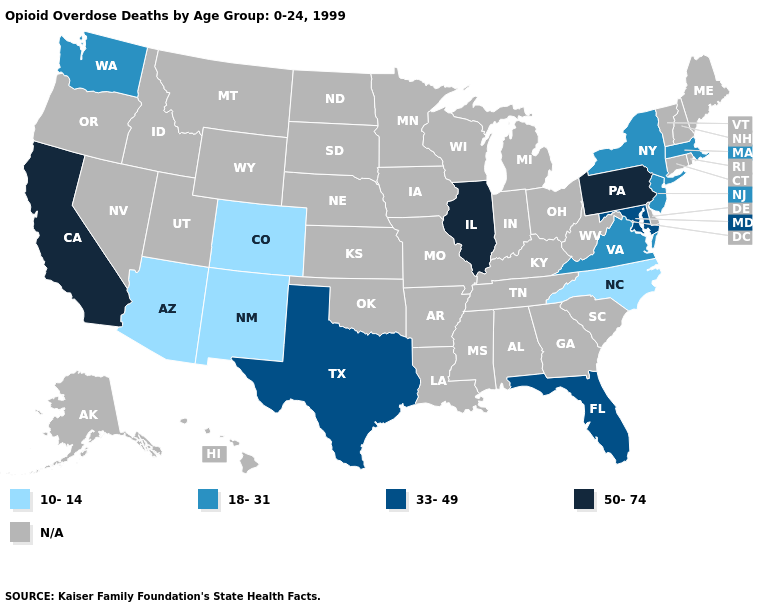Name the states that have a value in the range 33-49?
Write a very short answer. Florida, Maryland, Texas. Does New Jersey have the highest value in the USA?
Give a very brief answer. No. Name the states that have a value in the range N/A?
Give a very brief answer. Alabama, Alaska, Arkansas, Connecticut, Delaware, Georgia, Hawaii, Idaho, Indiana, Iowa, Kansas, Kentucky, Louisiana, Maine, Michigan, Minnesota, Mississippi, Missouri, Montana, Nebraska, Nevada, New Hampshire, North Dakota, Ohio, Oklahoma, Oregon, Rhode Island, South Carolina, South Dakota, Tennessee, Utah, Vermont, West Virginia, Wisconsin, Wyoming. Does Texas have the highest value in the South?
Concise answer only. Yes. Does Pennsylvania have the highest value in the USA?
Be succinct. Yes. How many symbols are there in the legend?
Short answer required. 5. Name the states that have a value in the range 33-49?
Concise answer only. Florida, Maryland, Texas. Does Pennsylvania have the highest value in the USA?
Short answer required. Yes. What is the value of Missouri?
Write a very short answer. N/A. Is the legend a continuous bar?
Quick response, please. No. Which states have the highest value in the USA?
Quick response, please. California, Illinois, Pennsylvania. Name the states that have a value in the range N/A?
Quick response, please. Alabama, Alaska, Arkansas, Connecticut, Delaware, Georgia, Hawaii, Idaho, Indiana, Iowa, Kansas, Kentucky, Louisiana, Maine, Michigan, Minnesota, Mississippi, Missouri, Montana, Nebraska, Nevada, New Hampshire, North Dakota, Ohio, Oklahoma, Oregon, Rhode Island, South Carolina, South Dakota, Tennessee, Utah, Vermont, West Virginia, Wisconsin, Wyoming. What is the highest value in states that border Nebraska?
Answer briefly. 10-14. Does Pennsylvania have the lowest value in the Northeast?
Answer briefly. No. 